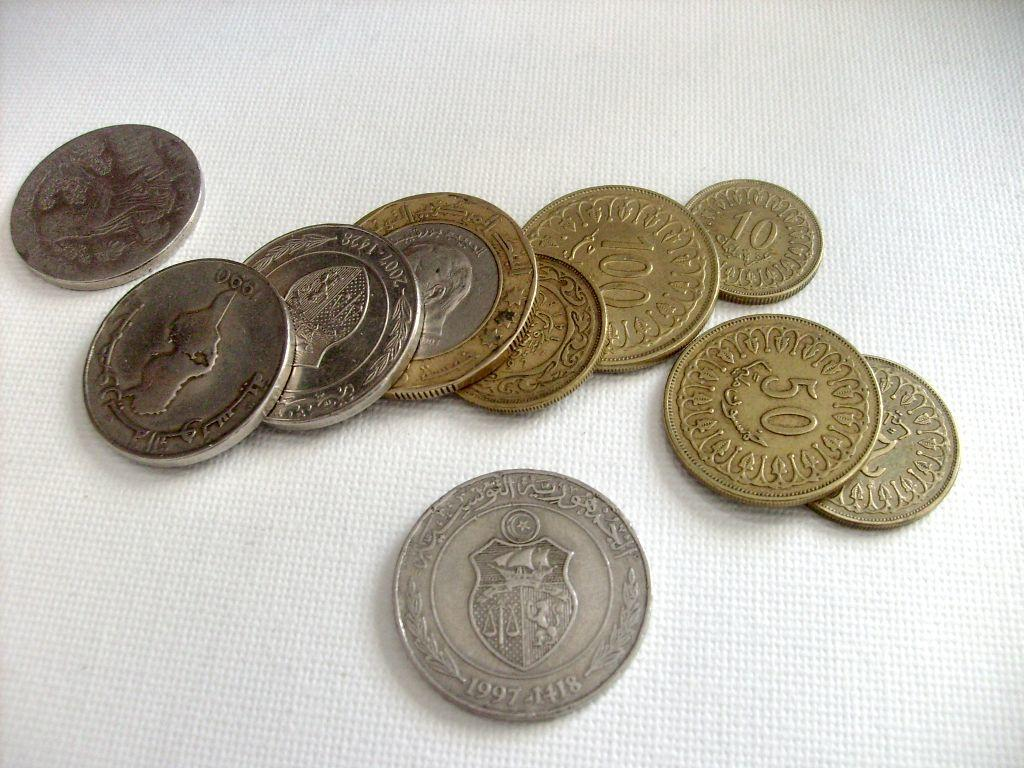<image>
Describe the image concisely. A collection of coins is on a white cloth, one of which has a denomination of 50. 